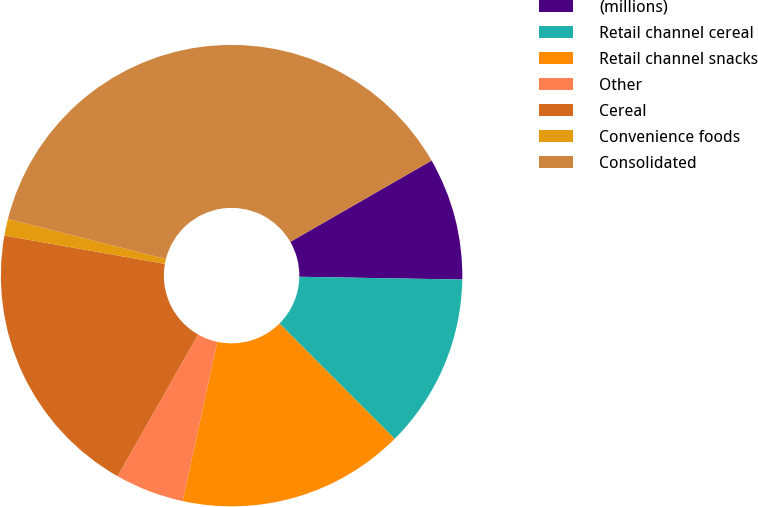Convert chart to OTSL. <chart><loc_0><loc_0><loc_500><loc_500><pie_chart><fcel>(millions)<fcel>Retail channel cereal<fcel>Retail channel snacks<fcel>Other<fcel>Cereal<fcel>Convenience foods<fcel>Consolidated<nl><fcel>8.58%<fcel>12.24%<fcel>15.89%<fcel>4.83%<fcel>19.55%<fcel>1.17%<fcel>37.74%<nl></chart> 